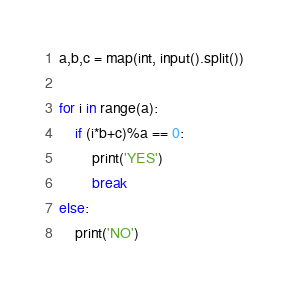<code> <loc_0><loc_0><loc_500><loc_500><_Python_>a,b,c = map(int, input().split())

for i in range(a):
    if (i*b+c)%a == 0:
        print('YES')
        break
else:
    print('NO')
</code> 